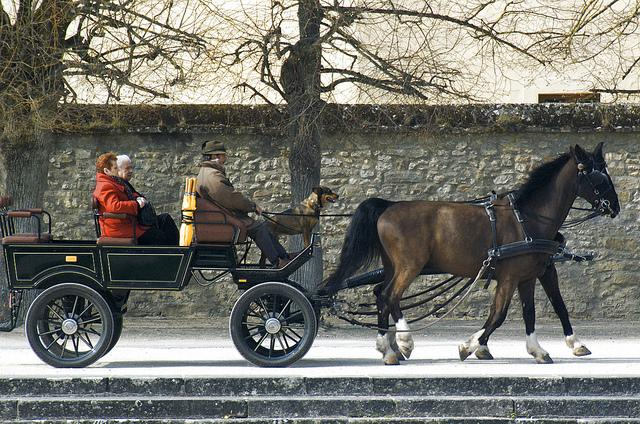In which season are the people traveling on the black horse drawn coach?

Choices:
A) summer
B) spring
C) fall
D) winter winter 